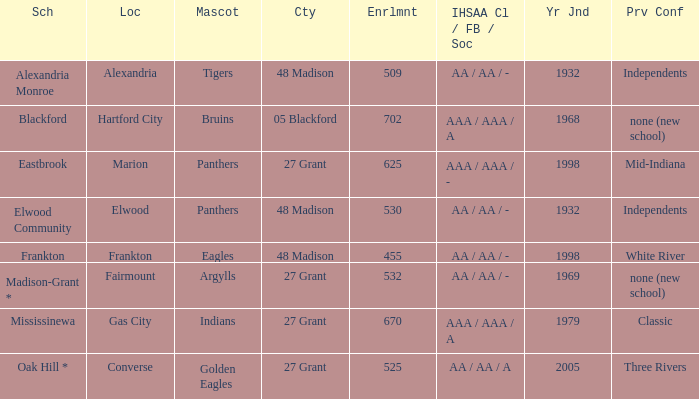What is teh ihsaa class/football/soccer when the location is alexandria? AA / AA / -. 